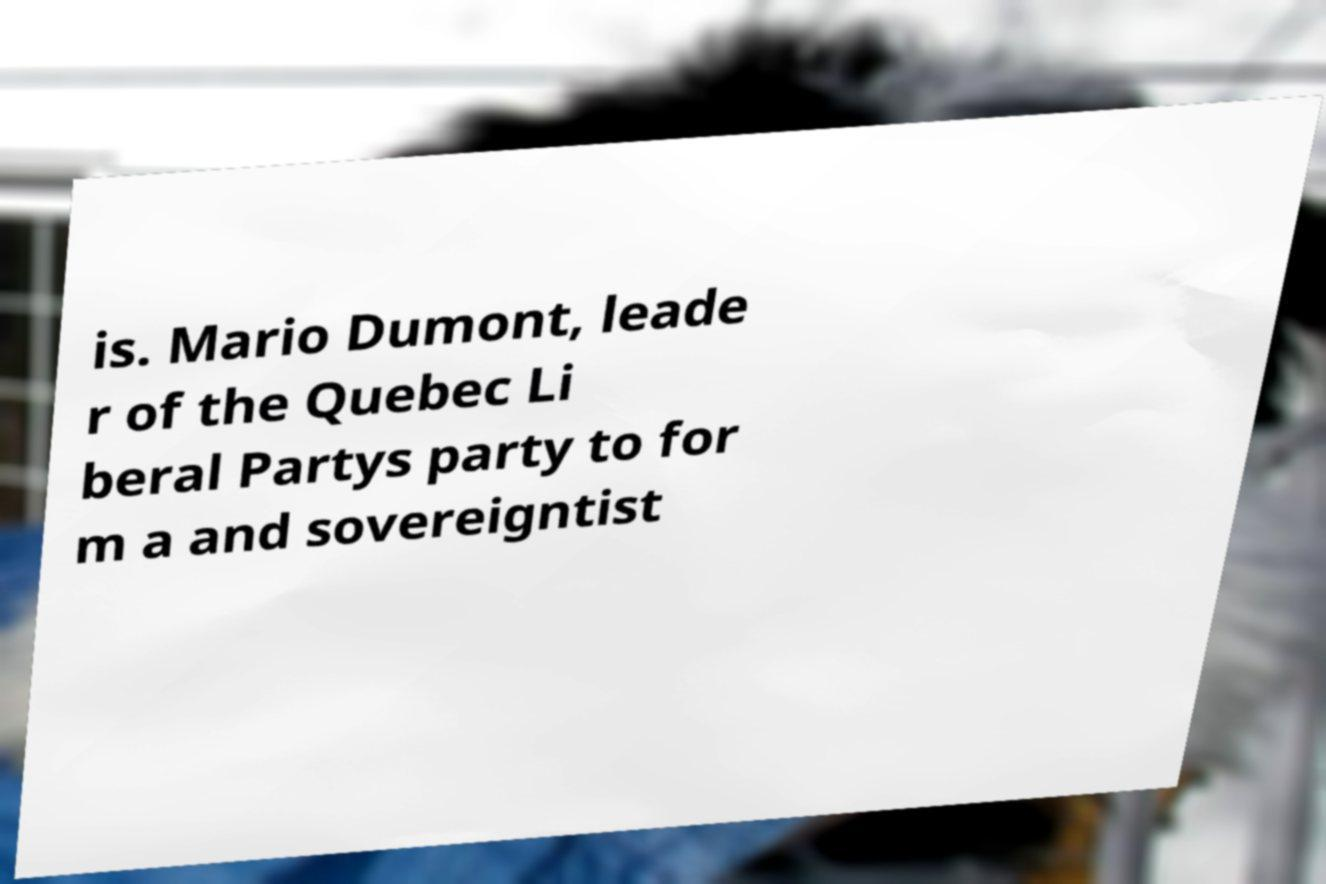I need the written content from this picture converted into text. Can you do that? is. Mario Dumont, leade r of the Quebec Li beral Partys party to for m a and sovereigntist 